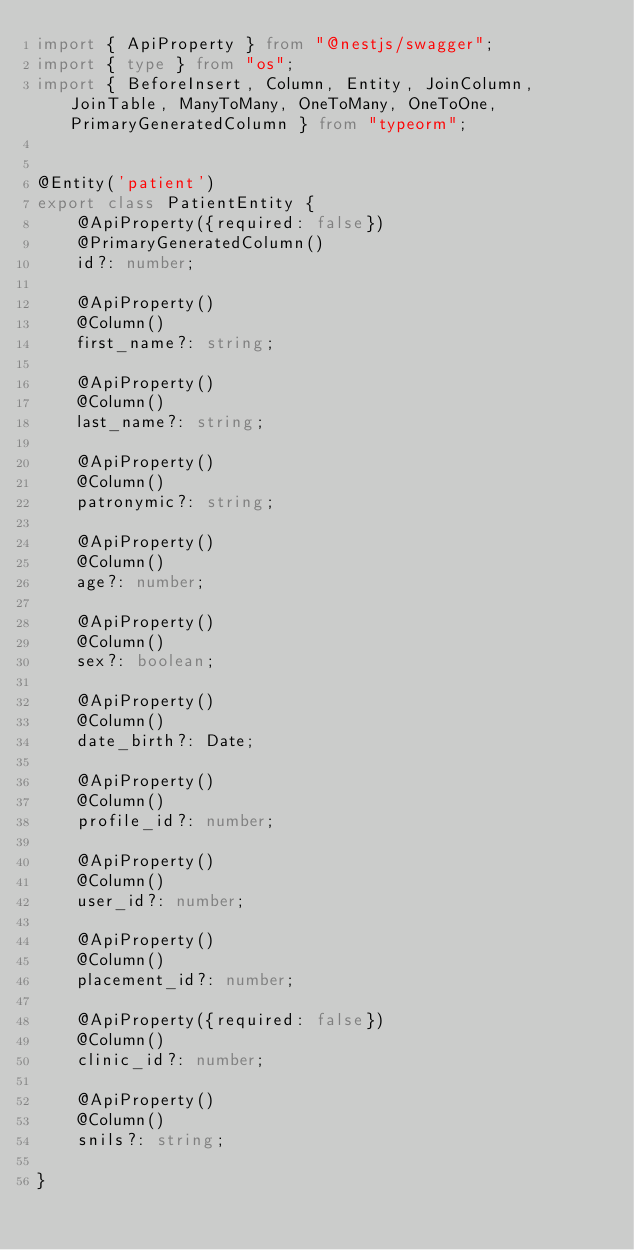<code> <loc_0><loc_0><loc_500><loc_500><_TypeScript_>import { ApiProperty } from "@nestjs/swagger";
import { type } from "os";
import { BeforeInsert, Column, Entity, JoinColumn, JoinTable, ManyToMany, OneToMany, OneToOne, PrimaryGeneratedColumn } from "typeorm";


@Entity('patient')
export class PatientEntity {
    @ApiProperty({required: false})
    @PrimaryGeneratedColumn()
    id?: number;

    @ApiProperty()
    @Column()
    first_name?: string;

    @ApiProperty()
    @Column()
    last_name?: string;

    @ApiProperty()
    @Column()
    patronymic?: string;

    @ApiProperty()
    @Column()
    age?: number;

    @ApiProperty()
    @Column()
    sex?: boolean;

    @ApiProperty()
    @Column()
    date_birth?: Date;

    @ApiProperty()
    @Column()
    profile_id?: number;

    @ApiProperty()
    @Column()
    user_id?: number;
    
    @ApiProperty()
    @Column()
    placement_id?: number;

    @ApiProperty({required: false})
    @Column()
    clinic_id?: number;

    @ApiProperty()
    @Column()
    snils?: string;

}</code> 